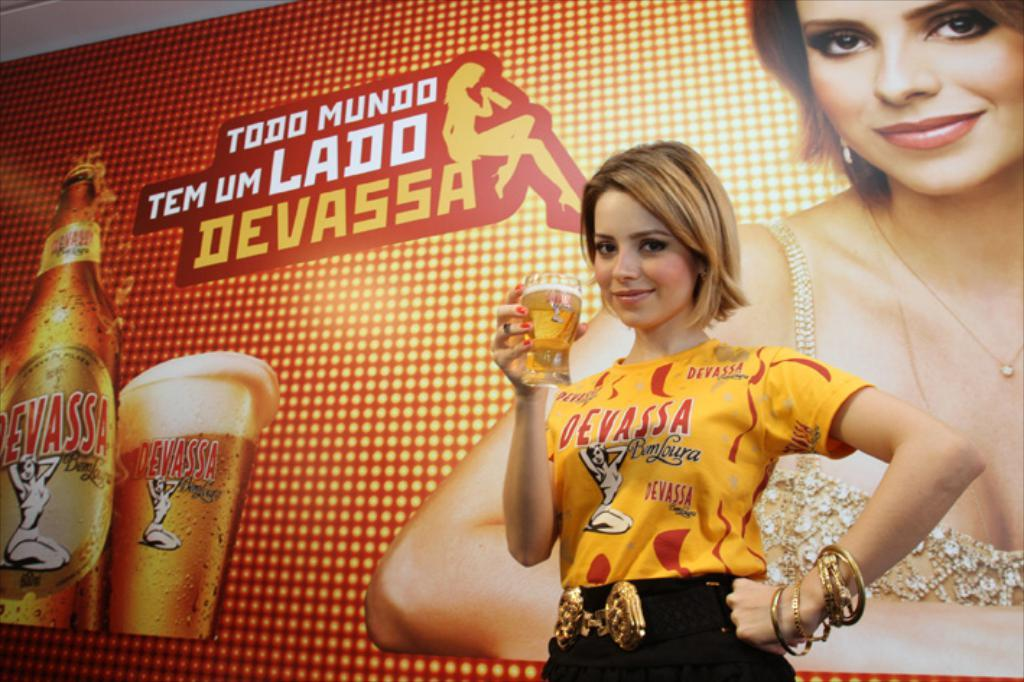<image>
Provide a brief description of the given image. A female, holding a glass of beer, is wearing a shirt that says "Devassa" on it while standing in front of a Devassa sign. 